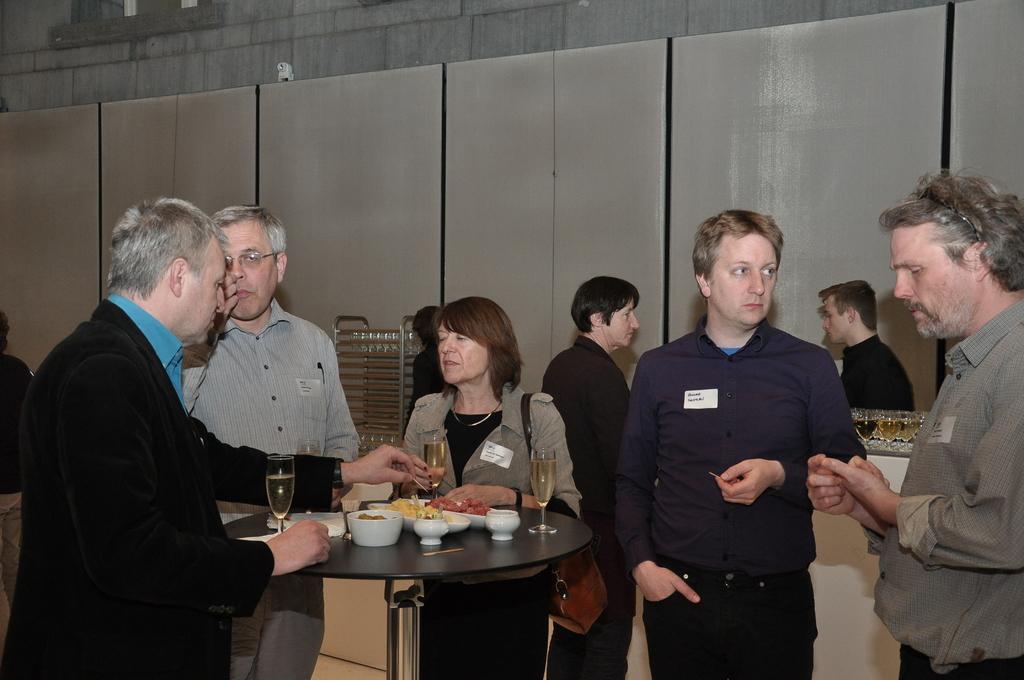Describe this image in one or two sentences. In this image, group of people are standing, few are holding a wine glasses. At the center, there is a table, few items are placed on it. Woman is wearing a bag. And back side, we can see wall. 